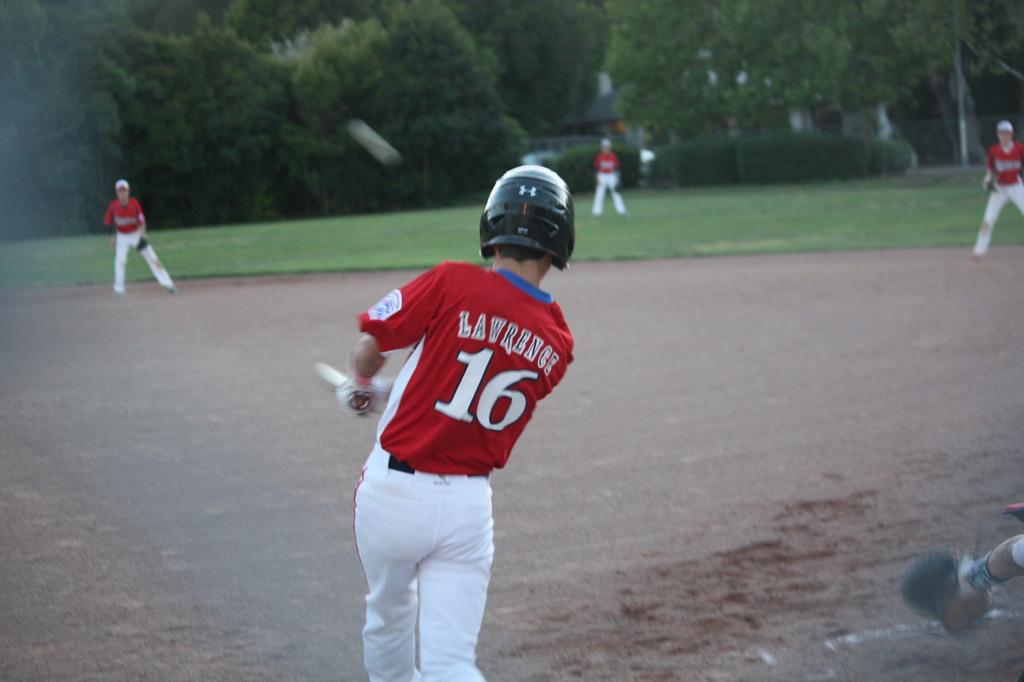Provide a one-sentence caption for the provided image. Lawrence, wearing number 16 has, just swung at a pitch. 